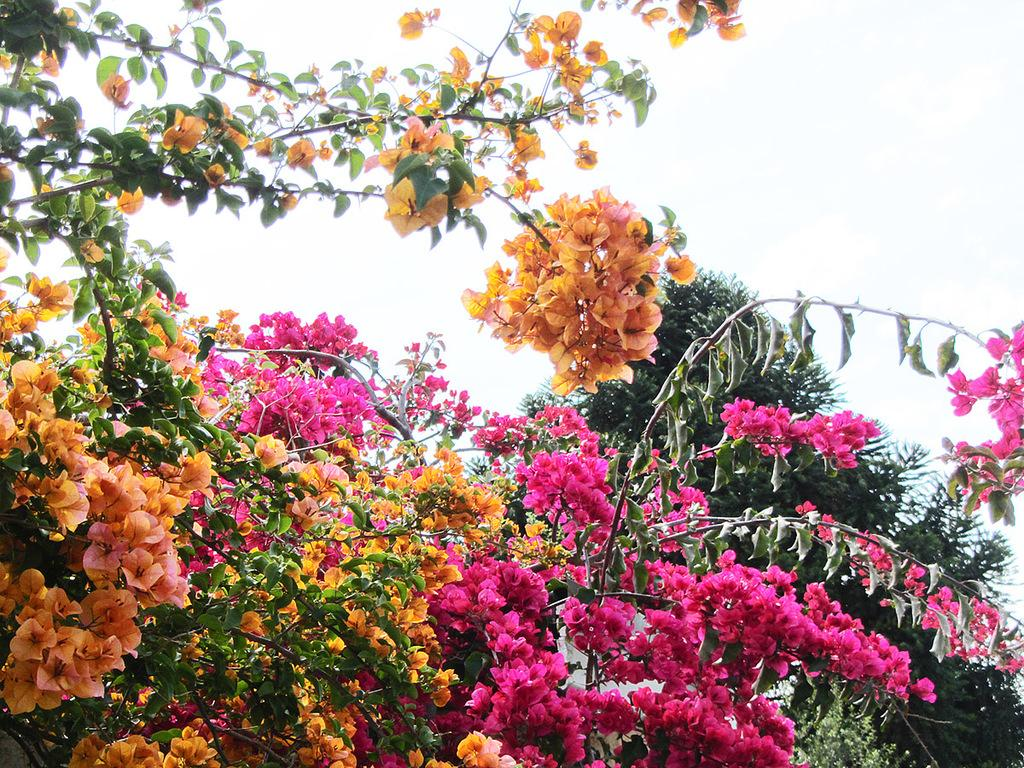What type of plants can be seen in the image? There are flower plants in the image. What colors are the flowers? The flowers are in orange and pink colors. What type of metal is the stem of the rose in the image made of? There is no rose present in the image, and therefore no stem or metal can be observed. 